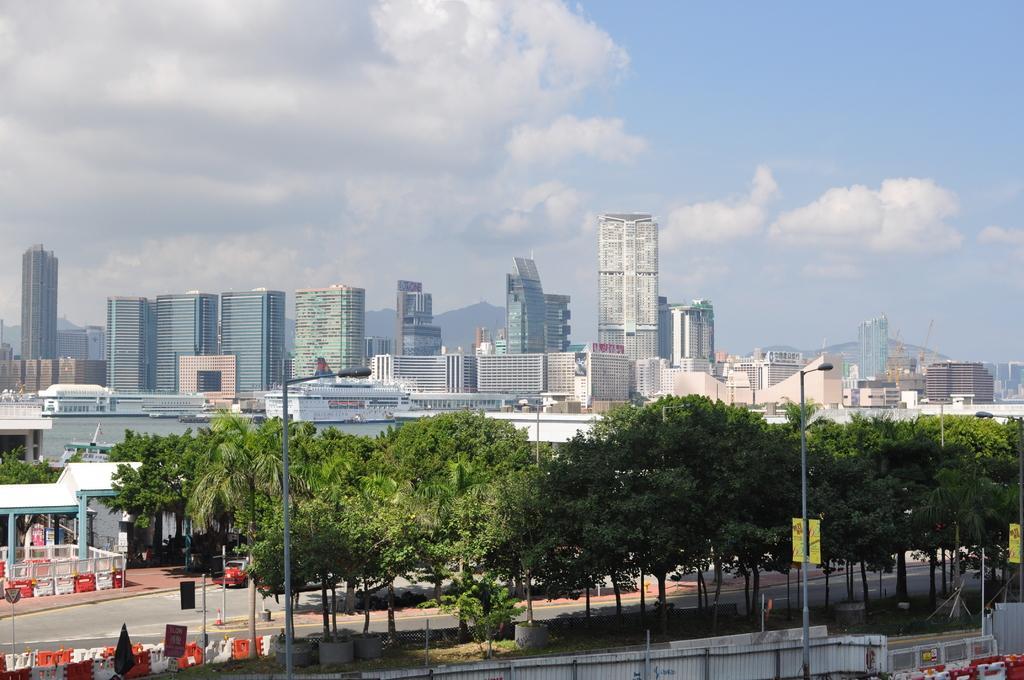Describe this image in one or two sentences. Sky is cloudy. In this image we can see buildings, light poles, hoardings, fence and trees. 